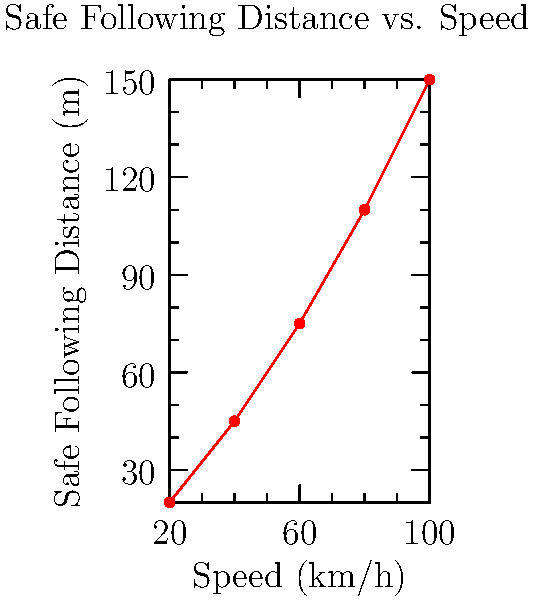As a traffic safety influencer, you're creating a social media post about safe following distances. Using the graph, which shows the relationship between vehicle speed and safe following distance, determine the equation that best represents this relationship. Assume the safe following distance (D) is a function of speed (v) in the form $D = av^2 + bv + c$, where a, b, and c are constants. What is the approximate value of 'a' in this equation? To determine the value of 'a' in the equation $D = av^2 + bv + c$, we'll follow these steps:

1) First, we need to recognize that this is a quadratic equation, and the graph shows a curved line that resembles a parabola, which is consistent with a quadratic relationship.

2) To find 'a', we'll use the general form of a quadratic equation: $y = ax^2 + bx + c$

3) In our case, y represents the safe following distance (D), and x represents the speed (v).

4) The coefficient 'a' determines the steepness of the parabola. A positive 'a' means the parabola opens upward, which matches our graph.

5) To estimate 'a', we can use the following approximation:

   $a \approx \frac{y_2 - 2y_1 + y_0}{(x_1 - x_0)^2}$

   Where $(x_0, y_0)$, $(x_1, y_1)$, and $(x_2, y_2)$ are three points on the curve.

6) Let's choose three points from the graph:
   $(20, 20)$, $(60, 75)$, and $(100, 150)$

7) Plugging these into our approximation:

   $a \approx \frac{150 - 2(75) + 20}{(100 - 20)^2} = \frac{20}{6400} = 0.003125$

8) Rounding to three decimal places, we get $a \approx 0.003$

Therefore, the approximate value of 'a' in the equation $D = av^2 + bv + c$ is 0.003.
Answer: 0.003 